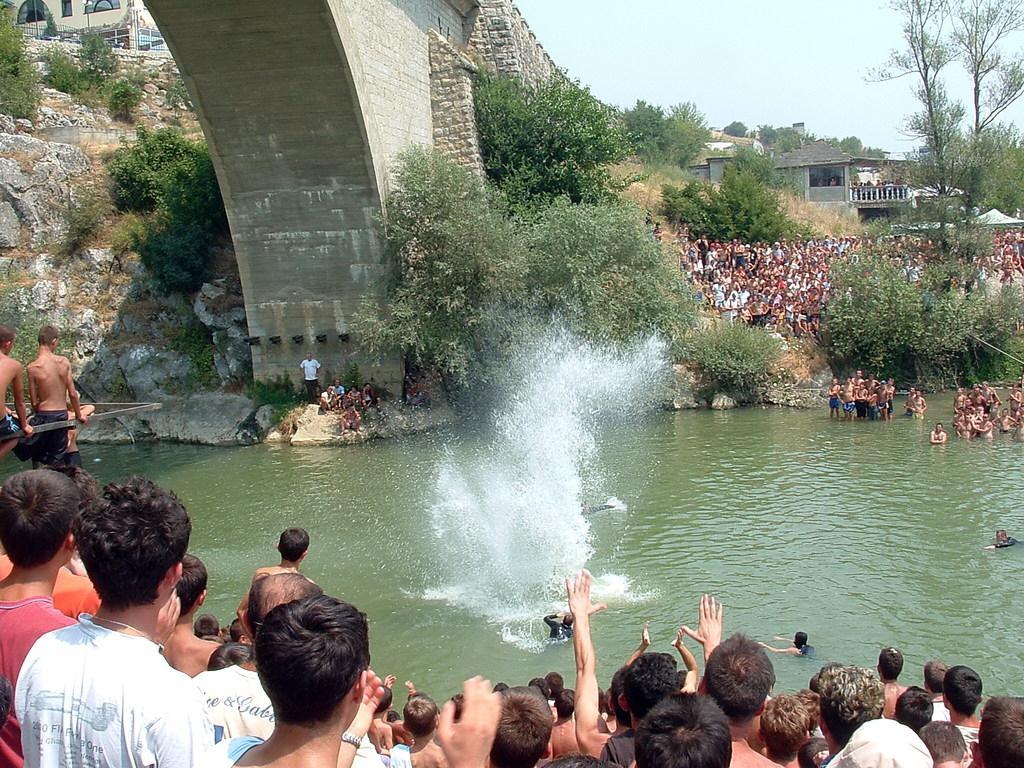Could you give a brief overview of what you see in this image? In this image, there are a few people, houses, trees, plants. We can see some water and the bridge. We can also see the sky and some stones. 